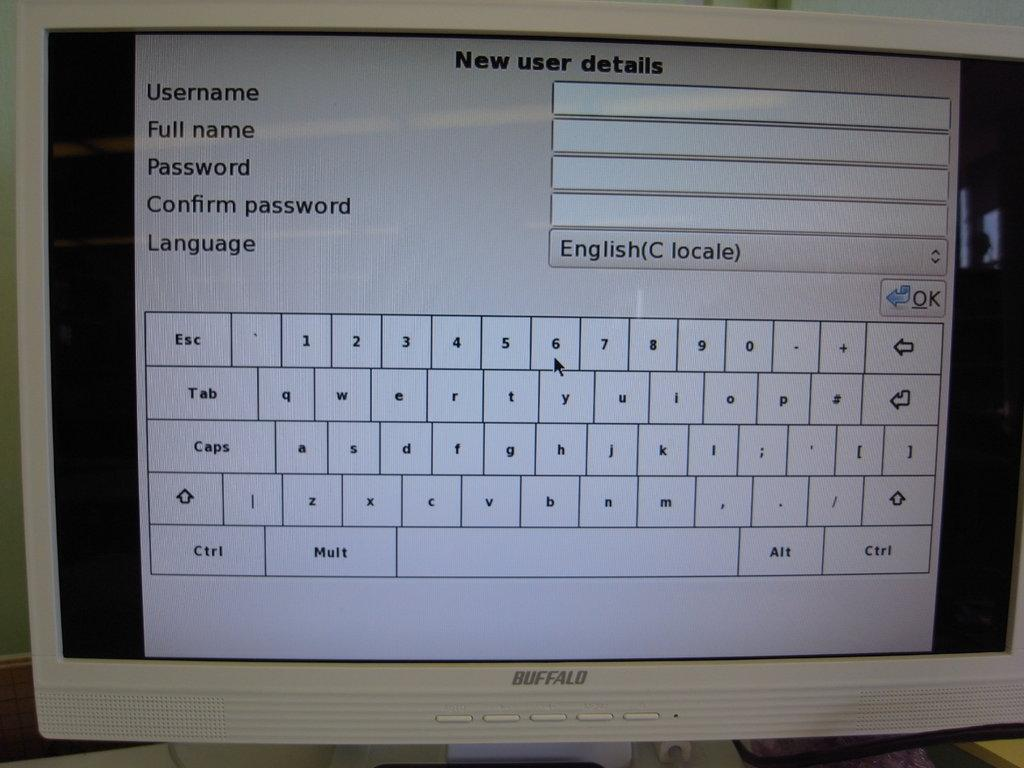<image>
Present a compact description of the photo's key features. A Buffalo monitor is displaying a new user registration page. 